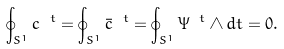<formula> <loc_0><loc_0><loc_500><loc_500>\oint _ { S ^ { 1 } } c ^ { \ t } = \oint _ { S ^ { 1 } } \bar { c } ^ { \ t } = \oint _ { S ^ { 1 } } \Psi ^ { \ t } \wedge d t = 0 .</formula> 